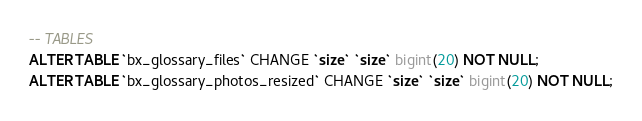Convert code to text. <code><loc_0><loc_0><loc_500><loc_500><_SQL_>-- TABLES
ALTER TABLE `bx_glossary_files` CHANGE `size` `size` bigint(20) NOT NULL;
ALTER TABLE `bx_glossary_photos_resized` CHANGE `size` `size` bigint(20) NOT NULL;
</code> 